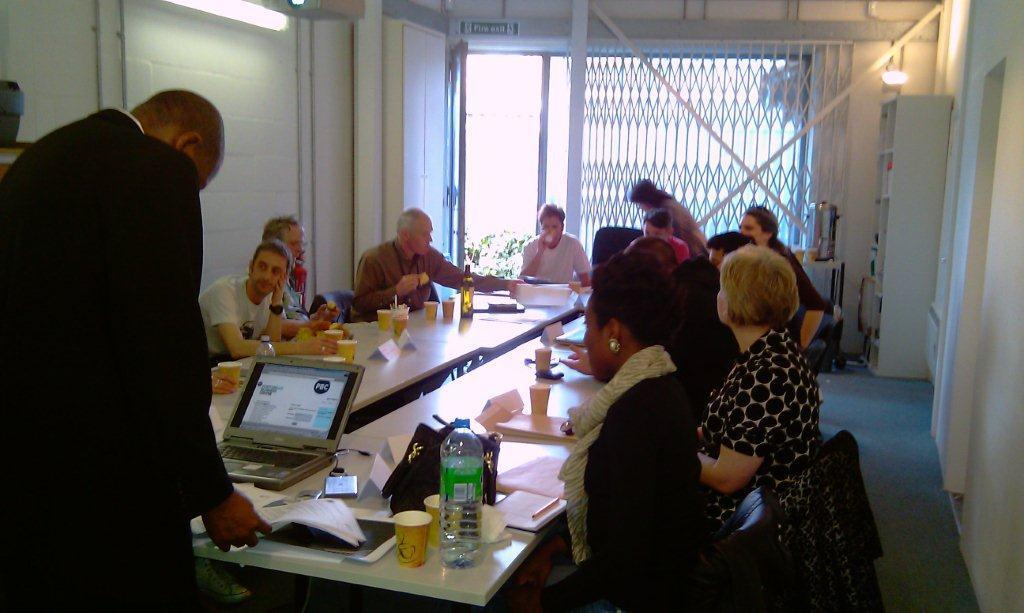What is the man on the left side of the image doing? The man is standing on the left side of the image and holding papers. What can be seen in the center of the image? There are people sitting around a table. Is there any source of light visible in the image? Yes, there is a light on the wall on the left side of the image. What type of air is being discussed by the lawyer in the image? There is no lawyer present in the image, and no discussion about air can be observed. 